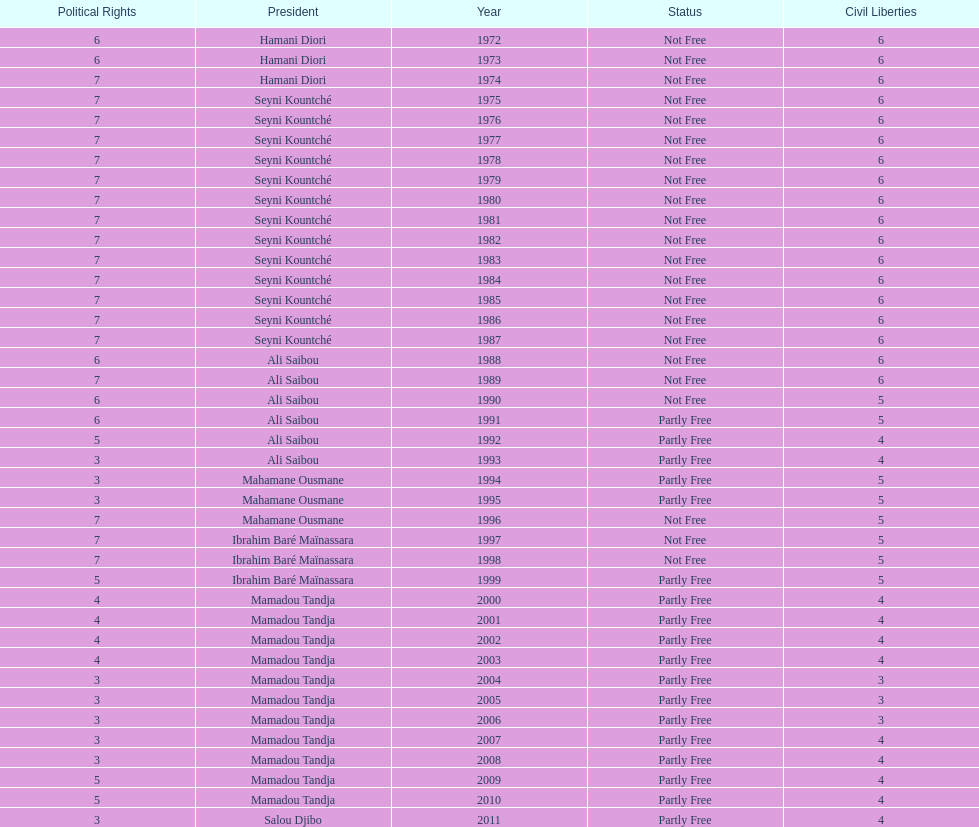How long did it take for civil liberties to decrease below 6? 18 years. 